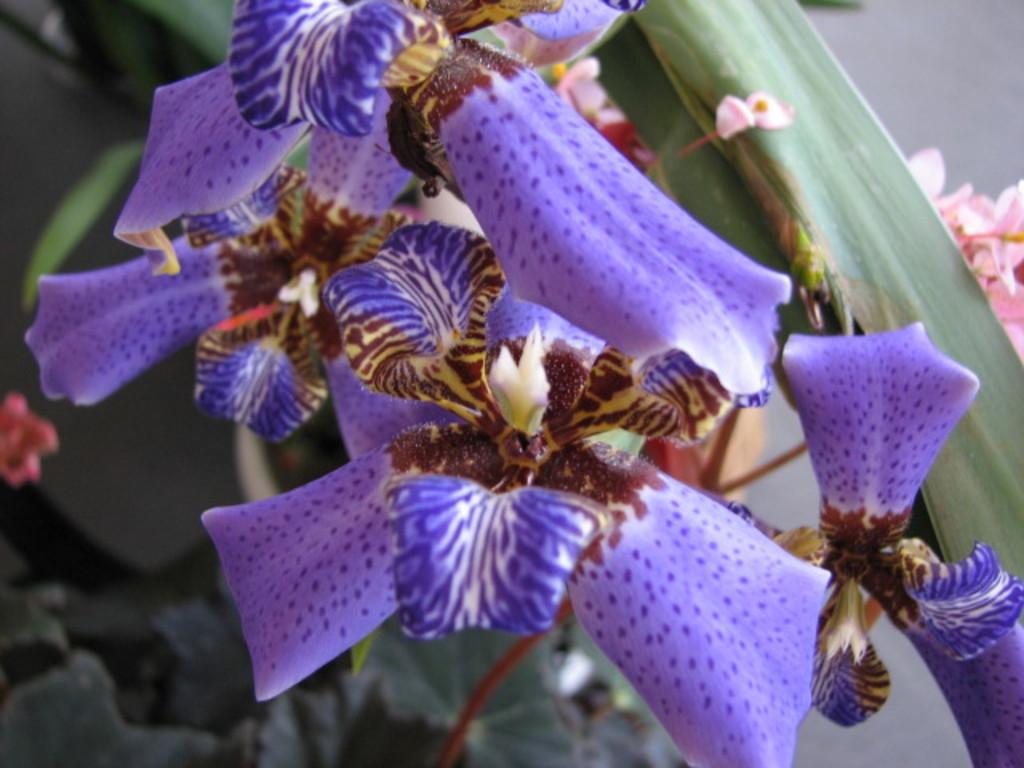Can you describe this image briefly? In the middle of this image I can see some flowers. Its petals are in violet color and on the petals I can see black color dots. On the right side there are some other flowers. In the background few leaves are visible. 